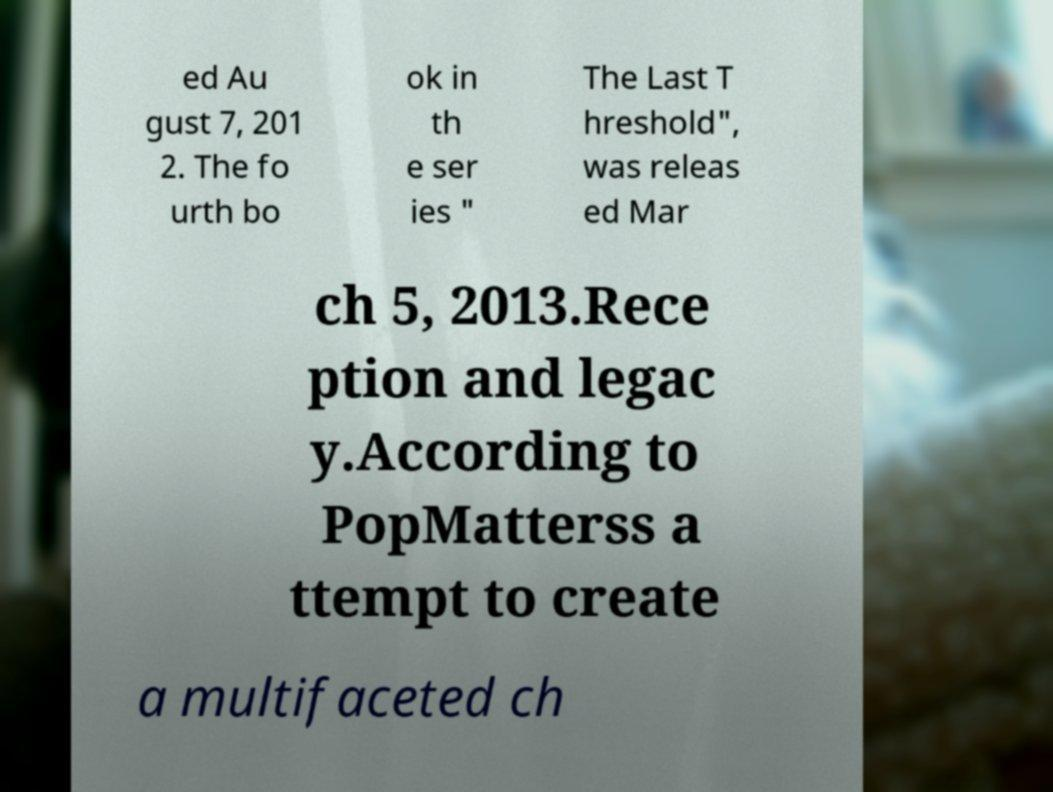What messages or text are displayed in this image? I need them in a readable, typed format. ed Au gust 7, 201 2. The fo urth bo ok in th e ser ies " The Last T hreshold", was releas ed Mar ch 5, 2013.Rece ption and legac y.According to PopMatterss a ttempt to create a multifaceted ch 